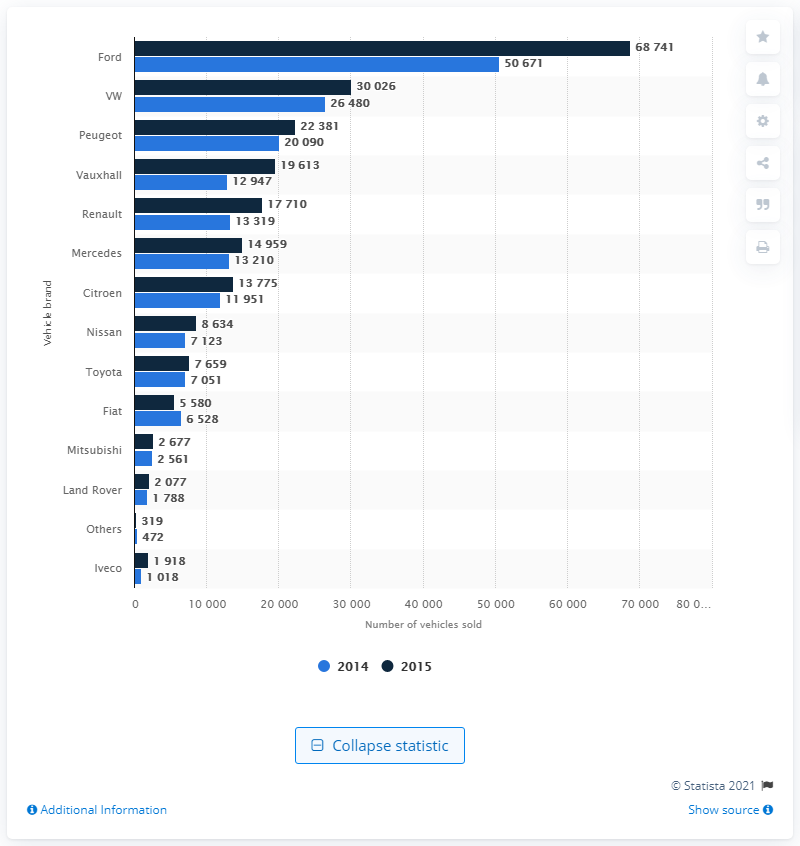Highlight a few significant elements in this photo. Ford saw the largest increase in fleet van sales among American brands. Vauxhall experienced the greatest percentage growth in fleet van sales among all brands, making it a standout in the industry. 